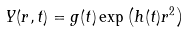<formula> <loc_0><loc_0><loc_500><loc_500>Y ( r , t ) = g ( t ) \exp \left ( h ( t ) r ^ { 2 } \right )</formula> 